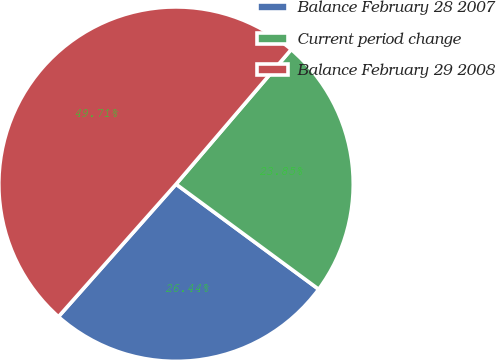<chart> <loc_0><loc_0><loc_500><loc_500><pie_chart><fcel>Balance February 28 2007<fcel>Current period change<fcel>Balance February 29 2008<nl><fcel>26.44%<fcel>23.85%<fcel>49.71%<nl></chart> 